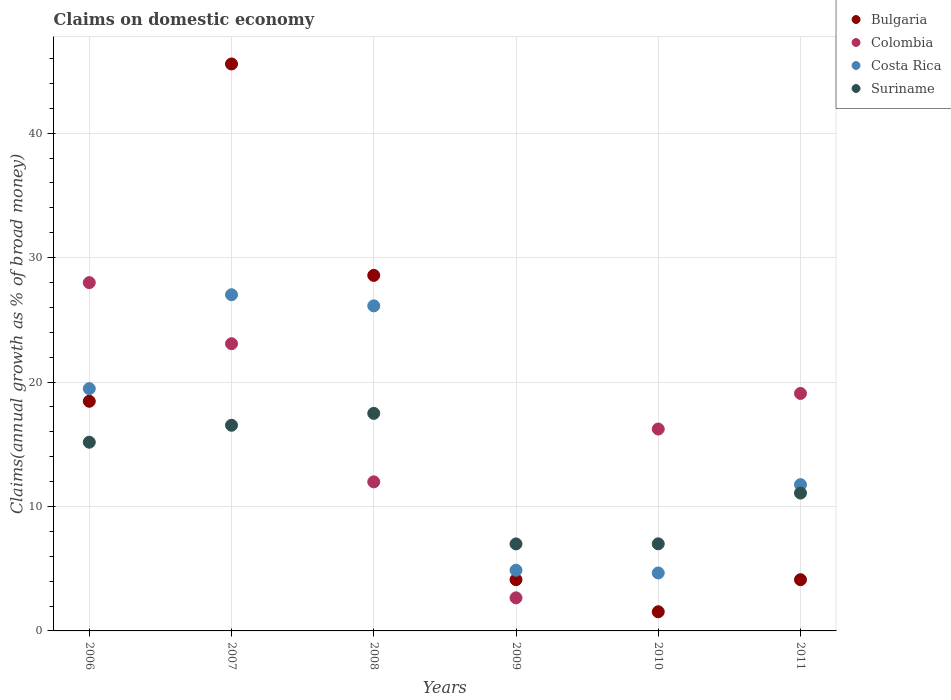How many different coloured dotlines are there?
Your response must be concise. 4. Is the number of dotlines equal to the number of legend labels?
Your response must be concise. Yes. What is the percentage of broad money claimed on domestic economy in Costa Rica in 2007?
Your answer should be very brief. 27.02. Across all years, what is the maximum percentage of broad money claimed on domestic economy in Bulgaria?
Ensure brevity in your answer.  45.56. Across all years, what is the minimum percentage of broad money claimed on domestic economy in Suriname?
Keep it short and to the point. 6.99. In which year was the percentage of broad money claimed on domestic economy in Bulgaria maximum?
Offer a very short reply. 2007. What is the total percentage of broad money claimed on domestic economy in Bulgaria in the graph?
Offer a very short reply. 102.36. What is the difference between the percentage of broad money claimed on domestic economy in Colombia in 2009 and that in 2011?
Your answer should be compact. -16.43. What is the difference between the percentage of broad money claimed on domestic economy in Bulgaria in 2008 and the percentage of broad money claimed on domestic economy in Suriname in 2009?
Make the answer very short. 21.58. What is the average percentage of broad money claimed on domestic economy in Bulgaria per year?
Ensure brevity in your answer.  17.06. In the year 2010, what is the difference between the percentage of broad money claimed on domestic economy in Suriname and percentage of broad money claimed on domestic economy in Costa Rica?
Make the answer very short. 2.34. What is the ratio of the percentage of broad money claimed on domestic economy in Costa Rica in 2006 to that in 2007?
Give a very brief answer. 0.72. Is the percentage of broad money claimed on domestic economy in Costa Rica in 2006 less than that in 2009?
Your response must be concise. No. What is the difference between the highest and the second highest percentage of broad money claimed on domestic economy in Bulgaria?
Keep it short and to the point. 16.99. What is the difference between the highest and the lowest percentage of broad money claimed on domestic economy in Suriname?
Ensure brevity in your answer.  10.49. In how many years, is the percentage of broad money claimed on domestic economy in Costa Rica greater than the average percentage of broad money claimed on domestic economy in Costa Rica taken over all years?
Your answer should be very brief. 3. Is the sum of the percentage of broad money claimed on domestic economy in Suriname in 2006 and 2007 greater than the maximum percentage of broad money claimed on domestic economy in Colombia across all years?
Your answer should be compact. Yes. Is the percentage of broad money claimed on domestic economy in Suriname strictly greater than the percentage of broad money claimed on domestic economy in Costa Rica over the years?
Make the answer very short. No. Is the percentage of broad money claimed on domestic economy in Colombia strictly less than the percentage of broad money claimed on domestic economy in Costa Rica over the years?
Give a very brief answer. No. How many dotlines are there?
Make the answer very short. 4. How many years are there in the graph?
Keep it short and to the point. 6. What is the difference between two consecutive major ticks on the Y-axis?
Your response must be concise. 10. Does the graph contain any zero values?
Your answer should be very brief. No. Does the graph contain grids?
Ensure brevity in your answer.  Yes. How many legend labels are there?
Provide a succinct answer. 4. What is the title of the graph?
Offer a terse response. Claims on domestic economy. Does "Canada" appear as one of the legend labels in the graph?
Your answer should be very brief. No. What is the label or title of the X-axis?
Make the answer very short. Years. What is the label or title of the Y-axis?
Offer a terse response. Claims(annual growth as % of broad money). What is the Claims(annual growth as % of broad money) in Bulgaria in 2006?
Your answer should be compact. 18.45. What is the Claims(annual growth as % of broad money) in Colombia in 2006?
Your response must be concise. 27.99. What is the Claims(annual growth as % of broad money) in Costa Rica in 2006?
Ensure brevity in your answer.  19.47. What is the Claims(annual growth as % of broad money) in Suriname in 2006?
Provide a succinct answer. 15.16. What is the Claims(annual growth as % of broad money) of Bulgaria in 2007?
Your answer should be very brief. 45.56. What is the Claims(annual growth as % of broad money) in Colombia in 2007?
Offer a very short reply. 23.08. What is the Claims(annual growth as % of broad money) of Costa Rica in 2007?
Your response must be concise. 27.02. What is the Claims(annual growth as % of broad money) in Suriname in 2007?
Your answer should be very brief. 16.53. What is the Claims(annual growth as % of broad money) of Bulgaria in 2008?
Provide a short and direct response. 28.57. What is the Claims(annual growth as % of broad money) of Colombia in 2008?
Offer a very short reply. 11.98. What is the Claims(annual growth as % of broad money) in Costa Rica in 2008?
Ensure brevity in your answer.  26.12. What is the Claims(annual growth as % of broad money) in Suriname in 2008?
Provide a short and direct response. 17.48. What is the Claims(annual growth as % of broad money) in Bulgaria in 2009?
Provide a succinct answer. 4.12. What is the Claims(annual growth as % of broad money) of Colombia in 2009?
Your answer should be compact. 2.66. What is the Claims(annual growth as % of broad money) of Costa Rica in 2009?
Ensure brevity in your answer.  4.88. What is the Claims(annual growth as % of broad money) of Suriname in 2009?
Provide a short and direct response. 6.99. What is the Claims(annual growth as % of broad money) in Bulgaria in 2010?
Offer a terse response. 1.54. What is the Claims(annual growth as % of broad money) in Colombia in 2010?
Keep it short and to the point. 16.22. What is the Claims(annual growth as % of broad money) of Costa Rica in 2010?
Make the answer very short. 4.66. What is the Claims(annual growth as % of broad money) in Suriname in 2010?
Keep it short and to the point. 7. What is the Claims(annual growth as % of broad money) in Bulgaria in 2011?
Offer a terse response. 4.12. What is the Claims(annual growth as % of broad money) in Colombia in 2011?
Keep it short and to the point. 19.08. What is the Claims(annual growth as % of broad money) of Costa Rica in 2011?
Your response must be concise. 11.75. What is the Claims(annual growth as % of broad money) of Suriname in 2011?
Make the answer very short. 11.08. Across all years, what is the maximum Claims(annual growth as % of broad money) in Bulgaria?
Provide a succinct answer. 45.56. Across all years, what is the maximum Claims(annual growth as % of broad money) in Colombia?
Your response must be concise. 27.99. Across all years, what is the maximum Claims(annual growth as % of broad money) in Costa Rica?
Offer a very short reply. 27.02. Across all years, what is the maximum Claims(annual growth as % of broad money) of Suriname?
Your answer should be compact. 17.48. Across all years, what is the minimum Claims(annual growth as % of broad money) in Bulgaria?
Give a very brief answer. 1.54. Across all years, what is the minimum Claims(annual growth as % of broad money) in Colombia?
Offer a very short reply. 2.66. Across all years, what is the minimum Claims(annual growth as % of broad money) in Costa Rica?
Give a very brief answer. 4.66. Across all years, what is the minimum Claims(annual growth as % of broad money) of Suriname?
Keep it short and to the point. 6.99. What is the total Claims(annual growth as % of broad money) of Bulgaria in the graph?
Your answer should be compact. 102.36. What is the total Claims(annual growth as % of broad money) in Colombia in the graph?
Keep it short and to the point. 101.01. What is the total Claims(annual growth as % of broad money) of Costa Rica in the graph?
Give a very brief answer. 93.89. What is the total Claims(annual growth as % of broad money) in Suriname in the graph?
Make the answer very short. 74.24. What is the difference between the Claims(annual growth as % of broad money) of Bulgaria in 2006 and that in 2007?
Provide a succinct answer. -27.11. What is the difference between the Claims(annual growth as % of broad money) of Colombia in 2006 and that in 2007?
Make the answer very short. 4.91. What is the difference between the Claims(annual growth as % of broad money) in Costa Rica in 2006 and that in 2007?
Provide a short and direct response. -7.55. What is the difference between the Claims(annual growth as % of broad money) in Suriname in 2006 and that in 2007?
Your answer should be very brief. -1.36. What is the difference between the Claims(annual growth as % of broad money) of Bulgaria in 2006 and that in 2008?
Ensure brevity in your answer.  -10.12. What is the difference between the Claims(annual growth as % of broad money) of Colombia in 2006 and that in 2008?
Ensure brevity in your answer.  16.01. What is the difference between the Claims(annual growth as % of broad money) in Costa Rica in 2006 and that in 2008?
Provide a short and direct response. -6.65. What is the difference between the Claims(annual growth as % of broad money) of Suriname in 2006 and that in 2008?
Keep it short and to the point. -2.32. What is the difference between the Claims(annual growth as % of broad money) of Bulgaria in 2006 and that in 2009?
Offer a terse response. 14.33. What is the difference between the Claims(annual growth as % of broad money) of Colombia in 2006 and that in 2009?
Provide a short and direct response. 25.33. What is the difference between the Claims(annual growth as % of broad money) in Costa Rica in 2006 and that in 2009?
Ensure brevity in your answer.  14.59. What is the difference between the Claims(annual growth as % of broad money) of Suriname in 2006 and that in 2009?
Keep it short and to the point. 8.17. What is the difference between the Claims(annual growth as % of broad money) of Bulgaria in 2006 and that in 2010?
Offer a very short reply. 16.91. What is the difference between the Claims(annual growth as % of broad money) in Colombia in 2006 and that in 2010?
Provide a short and direct response. 11.76. What is the difference between the Claims(annual growth as % of broad money) of Costa Rica in 2006 and that in 2010?
Your answer should be compact. 14.81. What is the difference between the Claims(annual growth as % of broad money) in Suriname in 2006 and that in 2010?
Your answer should be compact. 8.17. What is the difference between the Claims(annual growth as % of broad money) in Bulgaria in 2006 and that in 2011?
Keep it short and to the point. 14.34. What is the difference between the Claims(annual growth as % of broad money) in Colombia in 2006 and that in 2011?
Provide a succinct answer. 8.9. What is the difference between the Claims(annual growth as % of broad money) of Costa Rica in 2006 and that in 2011?
Provide a short and direct response. 7.72. What is the difference between the Claims(annual growth as % of broad money) in Suriname in 2006 and that in 2011?
Your answer should be very brief. 4.09. What is the difference between the Claims(annual growth as % of broad money) in Bulgaria in 2007 and that in 2008?
Give a very brief answer. 16.99. What is the difference between the Claims(annual growth as % of broad money) in Colombia in 2007 and that in 2008?
Provide a succinct answer. 11.1. What is the difference between the Claims(annual growth as % of broad money) of Costa Rica in 2007 and that in 2008?
Give a very brief answer. 0.89. What is the difference between the Claims(annual growth as % of broad money) of Suriname in 2007 and that in 2008?
Provide a succinct answer. -0.96. What is the difference between the Claims(annual growth as % of broad money) of Bulgaria in 2007 and that in 2009?
Offer a terse response. 41.44. What is the difference between the Claims(annual growth as % of broad money) in Colombia in 2007 and that in 2009?
Your answer should be very brief. 20.42. What is the difference between the Claims(annual growth as % of broad money) in Costa Rica in 2007 and that in 2009?
Give a very brief answer. 22.14. What is the difference between the Claims(annual growth as % of broad money) of Suriname in 2007 and that in 2009?
Your answer should be compact. 9.53. What is the difference between the Claims(annual growth as % of broad money) in Bulgaria in 2007 and that in 2010?
Offer a terse response. 44.02. What is the difference between the Claims(annual growth as % of broad money) of Colombia in 2007 and that in 2010?
Give a very brief answer. 6.86. What is the difference between the Claims(annual growth as % of broad money) in Costa Rica in 2007 and that in 2010?
Your answer should be compact. 22.36. What is the difference between the Claims(annual growth as % of broad money) in Suriname in 2007 and that in 2010?
Offer a very short reply. 9.53. What is the difference between the Claims(annual growth as % of broad money) of Bulgaria in 2007 and that in 2011?
Provide a succinct answer. 41.44. What is the difference between the Claims(annual growth as % of broad money) in Colombia in 2007 and that in 2011?
Ensure brevity in your answer.  4. What is the difference between the Claims(annual growth as % of broad money) of Costa Rica in 2007 and that in 2011?
Make the answer very short. 15.26. What is the difference between the Claims(annual growth as % of broad money) of Suriname in 2007 and that in 2011?
Your answer should be very brief. 5.45. What is the difference between the Claims(annual growth as % of broad money) of Bulgaria in 2008 and that in 2009?
Give a very brief answer. 24.45. What is the difference between the Claims(annual growth as % of broad money) of Colombia in 2008 and that in 2009?
Your answer should be compact. 9.32. What is the difference between the Claims(annual growth as % of broad money) in Costa Rica in 2008 and that in 2009?
Offer a terse response. 21.25. What is the difference between the Claims(annual growth as % of broad money) of Suriname in 2008 and that in 2009?
Provide a short and direct response. 10.49. What is the difference between the Claims(annual growth as % of broad money) of Bulgaria in 2008 and that in 2010?
Offer a very short reply. 27.03. What is the difference between the Claims(annual growth as % of broad money) in Colombia in 2008 and that in 2010?
Offer a terse response. -4.25. What is the difference between the Claims(annual growth as % of broad money) in Costa Rica in 2008 and that in 2010?
Your answer should be very brief. 21.46. What is the difference between the Claims(annual growth as % of broad money) in Suriname in 2008 and that in 2010?
Offer a very short reply. 10.48. What is the difference between the Claims(annual growth as % of broad money) in Bulgaria in 2008 and that in 2011?
Offer a very short reply. 24.45. What is the difference between the Claims(annual growth as % of broad money) in Colombia in 2008 and that in 2011?
Offer a terse response. -7.11. What is the difference between the Claims(annual growth as % of broad money) in Costa Rica in 2008 and that in 2011?
Your answer should be compact. 14.37. What is the difference between the Claims(annual growth as % of broad money) of Suriname in 2008 and that in 2011?
Ensure brevity in your answer.  6.4. What is the difference between the Claims(annual growth as % of broad money) of Bulgaria in 2009 and that in 2010?
Ensure brevity in your answer.  2.58. What is the difference between the Claims(annual growth as % of broad money) in Colombia in 2009 and that in 2010?
Offer a terse response. -13.57. What is the difference between the Claims(annual growth as % of broad money) of Costa Rica in 2009 and that in 2010?
Provide a short and direct response. 0.22. What is the difference between the Claims(annual growth as % of broad money) of Suriname in 2009 and that in 2010?
Ensure brevity in your answer.  -0.01. What is the difference between the Claims(annual growth as % of broad money) of Bulgaria in 2009 and that in 2011?
Your answer should be very brief. 0. What is the difference between the Claims(annual growth as % of broad money) of Colombia in 2009 and that in 2011?
Keep it short and to the point. -16.43. What is the difference between the Claims(annual growth as % of broad money) in Costa Rica in 2009 and that in 2011?
Your answer should be very brief. -6.88. What is the difference between the Claims(annual growth as % of broad money) of Suriname in 2009 and that in 2011?
Your answer should be very brief. -4.09. What is the difference between the Claims(annual growth as % of broad money) of Bulgaria in 2010 and that in 2011?
Your answer should be compact. -2.58. What is the difference between the Claims(annual growth as % of broad money) of Colombia in 2010 and that in 2011?
Offer a terse response. -2.86. What is the difference between the Claims(annual growth as % of broad money) of Costa Rica in 2010 and that in 2011?
Make the answer very short. -7.1. What is the difference between the Claims(annual growth as % of broad money) in Suriname in 2010 and that in 2011?
Provide a succinct answer. -4.08. What is the difference between the Claims(annual growth as % of broad money) of Bulgaria in 2006 and the Claims(annual growth as % of broad money) of Colombia in 2007?
Your answer should be compact. -4.63. What is the difference between the Claims(annual growth as % of broad money) of Bulgaria in 2006 and the Claims(annual growth as % of broad money) of Costa Rica in 2007?
Provide a short and direct response. -8.56. What is the difference between the Claims(annual growth as % of broad money) of Bulgaria in 2006 and the Claims(annual growth as % of broad money) of Suriname in 2007?
Your response must be concise. 1.93. What is the difference between the Claims(annual growth as % of broad money) of Colombia in 2006 and the Claims(annual growth as % of broad money) of Costa Rica in 2007?
Provide a short and direct response. 0.97. What is the difference between the Claims(annual growth as % of broad money) in Colombia in 2006 and the Claims(annual growth as % of broad money) in Suriname in 2007?
Give a very brief answer. 11.46. What is the difference between the Claims(annual growth as % of broad money) of Costa Rica in 2006 and the Claims(annual growth as % of broad money) of Suriname in 2007?
Your answer should be compact. 2.94. What is the difference between the Claims(annual growth as % of broad money) in Bulgaria in 2006 and the Claims(annual growth as % of broad money) in Colombia in 2008?
Give a very brief answer. 6.48. What is the difference between the Claims(annual growth as % of broad money) in Bulgaria in 2006 and the Claims(annual growth as % of broad money) in Costa Rica in 2008?
Keep it short and to the point. -7.67. What is the difference between the Claims(annual growth as % of broad money) of Colombia in 2006 and the Claims(annual growth as % of broad money) of Costa Rica in 2008?
Offer a very short reply. 1.87. What is the difference between the Claims(annual growth as % of broad money) of Colombia in 2006 and the Claims(annual growth as % of broad money) of Suriname in 2008?
Provide a succinct answer. 10.51. What is the difference between the Claims(annual growth as % of broad money) of Costa Rica in 2006 and the Claims(annual growth as % of broad money) of Suriname in 2008?
Your answer should be very brief. 1.99. What is the difference between the Claims(annual growth as % of broad money) of Bulgaria in 2006 and the Claims(annual growth as % of broad money) of Colombia in 2009?
Provide a short and direct response. 15.8. What is the difference between the Claims(annual growth as % of broad money) of Bulgaria in 2006 and the Claims(annual growth as % of broad money) of Costa Rica in 2009?
Offer a very short reply. 13.58. What is the difference between the Claims(annual growth as % of broad money) in Bulgaria in 2006 and the Claims(annual growth as % of broad money) in Suriname in 2009?
Offer a terse response. 11.46. What is the difference between the Claims(annual growth as % of broad money) in Colombia in 2006 and the Claims(annual growth as % of broad money) in Costa Rica in 2009?
Keep it short and to the point. 23.11. What is the difference between the Claims(annual growth as % of broad money) in Colombia in 2006 and the Claims(annual growth as % of broad money) in Suriname in 2009?
Offer a terse response. 21. What is the difference between the Claims(annual growth as % of broad money) of Costa Rica in 2006 and the Claims(annual growth as % of broad money) of Suriname in 2009?
Ensure brevity in your answer.  12.48. What is the difference between the Claims(annual growth as % of broad money) in Bulgaria in 2006 and the Claims(annual growth as % of broad money) in Colombia in 2010?
Make the answer very short. 2.23. What is the difference between the Claims(annual growth as % of broad money) in Bulgaria in 2006 and the Claims(annual growth as % of broad money) in Costa Rica in 2010?
Your answer should be compact. 13.8. What is the difference between the Claims(annual growth as % of broad money) in Bulgaria in 2006 and the Claims(annual growth as % of broad money) in Suriname in 2010?
Your answer should be very brief. 11.46. What is the difference between the Claims(annual growth as % of broad money) in Colombia in 2006 and the Claims(annual growth as % of broad money) in Costa Rica in 2010?
Your answer should be compact. 23.33. What is the difference between the Claims(annual growth as % of broad money) of Colombia in 2006 and the Claims(annual growth as % of broad money) of Suriname in 2010?
Offer a terse response. 20.99. What is the difference between the Claims(annual growth as % of broad money) of Costa Rica in 2006 and the Claims(annual growth as % of broad money) of Suriname in 2010?
Give a very brief answer. 12.47. What is the difference between the Claims(annual growth as % of broad money) in Bulgaria in 2006 and the Claims(annual growth as % of broad money) in Colombia in 2011?
Your answer should be very brief. -0.63. What is the difference between the Claims(annual growth as % of broad money) of Bulgaria in 2006 and the Claims(annual growth as % of broad money) of Costa Rica in 2011?
Ensure brevity in your answer.  6.7. What is the difference between the Claims(annual growth as % of broad money) of Bulgaria in 2006 and the Claims(annual growth as % of broad money) of Suriname in 2011?
Your answer should be very brief. 7.38. What is the difference between the Claims(annual growth as % of broad money) of Colombia in 2006 and the Claims(annual growth as % of broad money) of Costa Rica in 2011?
Keep it short and to the point. 16.23. What is the difference between the Claims(annual growth as % of broad money) in Colombia in 2006 and the Claims(annual growth as % of broad money) in Suriname in 2011?
Keep it short and to the point. 16.91. What is the difference between the Claims(annual growth as % of broad money) of Costa Rica in 2006 and the Claims(annual growth as % of broad money) of Suriname in 2011?
Provide a short and direct response. 8.39. What is the difference between the Claims(annual growth as % of broad money) in Bulgaria in 2007 and the Claims(annual growth as % of broad money) in Colombia in 2008?
Your response must be concise. 33.58. What is the difference between the Claims(annual growth as % of broad money) of Bulgaria in 2007 and the Claims(annual growth as % of broad money) of Costa Rica in 2008?
Provide a succinct answer. 19.44. What is the difference between the Claims(annual growth as % of broad money) of Bulgaria in 2007 and the Claims(annual growth as % of broad money) of Suriname in 2008?
Offer a terse response. 28.08. What is the difference between the Claims(annual growth as % of broad money) in Colombia in 2007 and the Claims(annual growth as % of broad money) in Costa Rica in 2008?
Offer a terse response. -3.04. What is the difference between the Claims(annual growth as % of broad money) of Colombia in 2007 and the Claims(annual growth as % of broad money) of Suriname in 2008?
Your response must be concise. 5.6. What is the difference between the Claims(annual growth as % of broad money) in Costa Rica in 2007 and the Claims(annual growth as % of broad money) in Suriname in 2008?
Ensure brevity in your answer.  9.53. What is the difference between the Claims(annual growth as % of broad money) of Bulgaria in 2007 and the Claims(annual growth as % of broad money) of Colombia in 2009?
Your answer should be compact. 42.9. What is the difference between the Claims(annual growth as % of broad money) of Bulgaria in 2007 and the Claims(annual growth as % of broad money) of Costa Rica in 2009?
Your response must be concise. 40.68. What is the difference between the Claims(annual growth as % of broad money) in Bulgaria in 2007 and the Claims(annual growth as % of broad money) in Suriname in 2009?
Give a very brief answer. 38.57. What is the difference between the Claims(annual growth as % of broad money) in Colombia in 2007 and the Claims(annual growth as % of broad money) in Costa Rica in 2009?
Your response must be concise. 18.2. What is the difference between the Claims(annual growth as % of broad money) of Colombia in 2007 and the Claims(annual growth as % of broad money) of Suriname in 2009?
Provide a short and direct response. 16.09. What is the difference between the Claims(annual growth as % of broad money) of Costa Rica in 2007 and the Claims(annual growth as % of broad money) of Suriname in 2009?
Offer a terse response. 20.02. What is the difference between the Claims(annual growth as % of broad money) of Bulgaria in 2007 and the Claims(annual growth as % of broad money) of Colombia in 2010?
Provide a short and direct response. 29.34. What is the difference between the Claims(annual growth as % of broad money) in Bulgaria in 2007 and the Claims(annual growth as % of broad money) in Costa Rica in 2010?
Your answer should be very brief. 40.9. What is the difference between the Claims(annual growth as % of broad money) of Bulgaria in 2007 and the Claims(annual growth as % of broad money) of Suriname in 2010?
Your answer should be very brief. 38.56. What is the difference between the Claims(annual growth as % of broad money) in Colombia in 2007 and the Claims(annual growth as % of broad money) in Costa Rica in 2010?
Provide a succinct answer. 18.42. What is the difference between the Claims(annual growth as % of broad money) of Colombia in 2007 and the Claims(annual growth as % of broad money) of Suriname in 2010?
Offer a terse response. 16.08. What is the difference between the Claims(annual growth as % of broad money) of Costa Rica in 2007 and the Claims(annual growth as % of broad money) of Suriname in 2010?
Make the answer very short. 20.02. What is the difference between the Claims(annual growth as % of broad money) of Bulgaria in 2007 and the Claims(annual growth as % of broad money) of Colombia in 2011?
Your answer should be compact. 26.48. What is the difference between the Claims(annual growth as % of broad money) in Bulgaria in 2007 and the Claims(annual growth as % of broad money) in Costa Rica in 2011?
Your response must be concise. 33.81. What is the difference between the Claims(annual growth as % of broad money) in Bulgaria in 2007 and the Claims(annual growth as % of broad money) in Suriname in 2011?
Your response must be concise. 34.48. What is the difference between the Claims(annual growth as % of broad money) in Colombia in 2007 and the Claims(annual growth as % of broad money) in Costa Rica in 2011?
Ensure brevity in your answer.  11.33. What is the difference between the Claims(annual growth as % of broad money) of Colombia in 2007 and the Claims(annual growth as % of broad money) of Suriname in 2011?
Your response must be concise. 12. What is the difference between the Claims(annual growth as % of broad money) of Costa Rica in 2007 and the Claims(annual growth as % of broad money) of Suriname in 2011?
Offer a terse response. 15.94. What is the difference between the Claims(annual growth as % of broad money) in Bulgaria in 2008 and the Claims(annual growth as % of broad money) in Colombia in 2009?
Offer a very short reply. 25.91. What is the difference between the Claims(annual growth as % of broad money) in Bulgaria in 2008 and the Claims(annual growth as % of broad money) in Costa Rica in 2009?
Ensure brevity in your answer.  23.69. What is the difference between the Claims(annual growth as % of broad money) of Bulgaria in 2008 and the Claims(annual growth as % of broad money) of Suriname in 2009?
Provide a short and direct response. 21.58. What is the difference between the Claims(annual growth as % of broad money) in Colombia in 2008 and the Claims(annual growth as % of broad money) in Costa Rica in 2009?
Ensure brevity in your answer.  7.1. What is the difference between the Claims(annual growth as % of broad money) of Colombia in 2008 and the Claims(annual growth as % of broad money) of Suriname in 2009?
Offer a very short reply. 4.99. What is the difference between the Claims(annual growth as % of broad money) in Costa Rica in 2008 and the Claims(annual growth as % of broad money) in Suriname in 2009?
Your answer should be compact. 19.13. What is the difference between the Claims(annual growth as % of broad money) of Bulgaria in 2008 and the Claims(annual growth as % of broad money) of Colombia in 2010?
Provide a short and direct response. 12.35. What is the difference between the Claims(annual growth as % of broad money) in Bulgaria in 2008 and the Claims(annual growth as % of broad money) in Costa Rica in 2010?
Ensure brevity in your answer.  23.91. What is the difference between the Claims(annual growth as % of broad money) in Bulgaria in 2008 and the Claims(annual growth as % of broad money) in Suriname in 2010?
Your answer should be very brief. 21.57. What is the difference between the Claims(annual growth as % of broad money) of Colombia in 2008 and the Claims(annual growth as % of broad money) of Costa Rica in 2010?
Your answer should be compact. 7.32. What is the difference between the Claims(annual growth as % of broad money) of Colombia in 2008 and the Claims(annual growth as % of broad money) of Suriname in 2010?
Provide a short and direct response. 4.98. What is the difference between the Claims(annual growth as % of broad money) in Costa Rica in 2008 and the Claims(annual growth as % of broad money) in Suriname in 2010?
Your answer should be compact. 19.12. What is the difference between the Claims(annual growth as % of broad money) in Bulgaria in 2008 and the Claims(annual growth as % of broad money) in Colombia in 2011?
Offer a very short reply. 9.49. What is the difference between the Claims(annual growth as % of broad money) in Bulgaria in 2008 and the Claims(annual growth as % of broad money) in Costa Rica in 2011?
Ensure brevity in your answer.  16.82. What is the difference between the Claims(annual growth as % of broad money) of Bulgaria in 2008 and the Claims(annual growth as % of broad money) of Suriname in 2011?
Ensure brevity in your answer.  17.49. What is the difference between the Claims(annual growth as % of broad money) in Colombia in 2008 and the Claims(annual growth as % of broad money) in Costa Rica in 2011?
Provide a short and direct response. 0.22. What is the difference between the Claims(annual growth as % of broad money) of Colombia in 2008 and the Claims(annual growth as % of broad money) of Suriname in 2011?
Your answer should be compact. 0.9. What is the difference between the Claims(annual growth as % of broad money) of Costa Rica in 2008 and the Claims(annual growth as % of broad money) of Suriname in 2011?
Offer a very short reply. 15.04. What is the difference between the Claims(annual growth as % of broad money) in Bulgaria in 2009 and the Claims(annual growth as % of broad money) in Colombia in 2010?
Offer a very short reply. -12.1. What is the difference between the Claims(annual growth as % of broad money) of Bulgaria in 2009 and the Claims(annual growth as % of broad money) of Costa Rica in 2010?
Make the answer very short. -0.54. What is the difference between the Claims(annual growth as % of broad money) in Bulgaria in 2009 and the Claims(annual growth as % of broad money) in Suriname in 2010?
Your answer should be compact. -2.88. What is the difference between the Claims(annual growth as % of broad money) in Colombia in 2009 and the Claims(annual growth as % of broad money) in Costa Rica in 2010?
Your response must be concise. -2. What is the difference between the Claims(annual growth as % of broad money) of Colombia in 2009 and the Claims(annual growth as % of broad money) of Suriname in 2010?
Offer a very short reply. -4.34. What is the difference between the Claims(annual growth as % of broad money) of Costa Rica in 2009 and the Claims(annual growth as % of broad money) of Suriname in 2010?
Your response must be concise. -2.12. What is the difference between the Claims(annual growth as % of broad money) of Bulgaria in 2009 and the Claims(annual growth as % of broad money) of Colombia in 2011?
Give a very brief answer. -14.96. What is the difference between the Claims(annual growth as % of broad money) in Bulgaria in 2009 and the Claims(annual growth as % of broad money) in Costa Rica in 2011?
Provide a short and direct response. -7.63. What is the difference between the Claims(annual growth as % of broad money) in Bulgaria in 2009 and the Claims(annual growth as % of broad money) in Suriname in 2011?
Offer a very short reply. -6.96. What is the difference between the Claims(annual growth as % of broad money) of Colombia in 2009 and the Claims(annual growth as % of broad money) of Costa Rica in 2011?
Your answer should be compact. -9.1. What is the difference between the Claims(annual growth as % of broad money) of Colombia in 2009 and the Claims(annual growth as % of broad money) of Suriname in 2011?
Your response must be concise. -8.42. What is the difference between the Claims(annual growth as % of broad money) of Costa Rica in 2009 and the Claims(annual growth as % of broad money) of Suriname in 2011?
Offer a terse response. -6.2. What is the difference between the Claims(annual growth as % of broad money) of Bulgaria in 2010 and the Claims(annual growth as % of broad money) of Colombia in 2011?
Give a very brief answer. -17.54. What is the difference between the Claims(annual growth as % of broad money) of Bulgaria in 2010 and the Claims(annual growth as % of broad money) of Costa Rica in 2011?
Your answer should be compact. -10.21. What is the difference between the Claims(annual growth as % of broad money) of Bulgaria in 2010 and the Claims(annual growth as % of broad money) of Suriname in 2011?
Give a very brief answer. -9.54. What is the difference between the Claims(annual growth as % of broad money) in Colombia in 2010 and the Claims(annual growth as % of broad money) in Costa Rica in 2011?
Provide a succinct answer. 4.47. What is the difference between the Claims(annual growth as % of broad money) in Colombia in 2010 and the Claims(annual growth as % of broad money) in Suriname in 2011?
Your answer should be compact. 5.15. What is the difference between the Claims(annual growth as % of broad money) in Costa Rica in 2010 and the Claims(annual growth as % of broad money) in Suriname in 2011?
Your response must be concise. -6.42. What is the average Claims(annual growth as % of broad money) in Bulgaria per year?
Make the answer very short. 17.06. What is the average Claims(annual growth as % of broad money) of Colombia per year?
Your answer should be compact. 16.84. What is the average Claims(annual growth as % of broad money) of Costa Rica per year?
Ensure brevity in your answer.  15.65. What is the average Claims(annual growth as % of broad money) in Suriname per year?
Keep it short and to the point. 12.37. In the year 2006, what is the difference between the Claims(annual growth as % of broad money) of Bulgaria and Claims(annual growth as % of broad money) of Colombia?
Offer a terse response. -9.53. In the year 2006, what is the difference between the Claims(annual growth as % of broad money) of Bulgaria and Claims(annual growth as % of broad money) of Costa Rica?
Keep it short and to the point. -1.02. In the year 2006, what is the difference between the Claims(annual growth as % of broad money) of Bulgaria and Claims(annual growth as % of broad money) of Suriname?
Make the answer very short. 3.29. In the year 2006, what is the difference between the Claims(annual growth as % of broad money) in Colombia and Claims(annual growth as % of broad money) in Costa Rica?
Make the answer very short. 8.52. In the year 2006, what is the difference between the Claims(annual growth as % of broad money) in Colombia and Claims(annual growth as % of broad money) in Suriname?
Offer a very short reply. 12.82. In the year 2006, what is the difference between the Claims(annual growth as % of broad money) in Costa Rica and Claims(annual growth as % of broad money) in Suriname?
Provide a short and direct response. 4.31. In the year 2007, what is the difference between the Claims(annual growth as % of broad money) of Bulgaria and Claims(annual growth as % of broad money) of Colombia?
Provide a short and direct response. 22.48. In the year 2007, what is the difference between the Claims(annual growth as % of broad money) of Bulgaria and Claims(annual growth as % of broad money) of Costa Rica?
Provide a succinct answer. 18.54. In the year 2007, what is the difference between the Claims(annual growth as % of broad money) of Bulgaria and Claims(annual growth as % of broad money) of Suriname?
Keep it short and to the point. 29.03. In the year 2007, what is the difference between the Claims(annual growth as % of broad money) in Colombia and Claims(annual growth as % of broad money) in Costa Rica?
Provide a short and direct response. -3.94. In the year 2007, what is the difference between the Claims(annual growth as % of broad money) in Colombia and Claims(annual growth as % of broad money) in Suriname?
Provide a succinct answer. 6.55. In the year 2007, what is the difference between the Claims(annual growth as % of broad money) of Costa Rica and Claims(annual growth as % of broad money) of Suriname?
Keep it short and to the point. 10.49. In the year 2008, what is the difference between the Claims(annual growth as % of broad money) in Bulgaria and Claims(annual growth as % of broad money) in Colombia?
Give a very brief answer. 16.59. In the year 2008, what is the difference between the Claims(annual growth as % of broad money) in Bulgaria and Claims(annual growth as % of broad money) in Costa Rica?
Make the answer very short. 2.45. In the year 2008, what is the difference between the Claims(annual growth as % of broad money) of Bulgaria and Claims(annual growth as % of broad money) of Suriname?
Offer a terse response. 11.09. In the year 2008, what is the difference between the Claims(annual growth as % of broad money) of Colombia and Claims(annual growth as % of broad money) of Costa Rica?
Keep it short and to the point. -14.14. In the year 2008, what is the difference between the Claims(annual growth as % of broad money) in Colombia and Claims(annual growth as % of broad money) in Suriname?
Offer a terse response. -5.5. In the year 2008, what is the difference between the Claims(annual growth as % of broad money) in Costa Rica and Claims(annual growth as % of broad money) in Suriname?
Your response must be concise. 8.64. In the year 2009, what is the difference between the Claims(annual growth as % of broad money) in Bulgaria and Claims(annual growth as % of broad money) in Colombia?
Make the answer very short. 1.46. In the year 2009, what is the difference between the Claims(annual growth as % of broad money) in Bulgaria and Claims(annual growth as % of broad money) in Costa Rica?
Offer a terse response. -0.76. In the year 2009, what is the difference between the Claims(annual growth as % of broad money) in Bulgaria and Claims(annual growth as % of broad money) in Suriname?
Provide a short and direct response. -2.87. In the year 2009, what is the difference between the Claims(annual growth as % of broad money) in Colombia and Claims(annual growth as % of broad money) in Costa Rica?
Give a very brief answer. -2.22. In the year 2009, what is the difference between the Claims(annual growth as % of broad money) in Colombia and Claims(annual growth as % of broad money) in Suriname?
Your response must be concise. -4.34. In the year 2009, what is the difference between the Claims(annual growth as % of broad money) of Costa Rica and Claims(annual growth as % of broad money) of Suriname?
Give a very brief answer. -2.12. In the year 2010, what is the difference between the Claims(annual growth as % of broad money) of Bulgaria and Claims(annual growth as % of broad money) of Colombia?
Ensure brevity in your answer.  -14.68. In the year 2010, what is the difference between the Claims(annual growth as % of broad money) of Bulgaria and Claims(annual growth as % of broad money) of Costa Rica?
Keep it short and to the point. -3.12. In the year 2010, what is the difference between the Claims(annual growth as % of broad money) of Bulgaria and Claims(annual growth as % of broad money) of Suriname?
Offer a very short reply. -5.46. In the year 2010, what is the difference between the Claims(annual growth as % of broad money) in Colombia and Claims(annual growth as % of broad money) in Costa Rica?
Your response must be concise. 11.57. In the year 2010, what is the difference between the Claims(annual growth as % of broad money) of Colombia and Claims(annual growth as % of broad money) of Suriname?
Provide a short and direct response. 9.23. In the year 2010, what is the difference between the Claims(annual growth as % of broad money) in Costa Rica and Claims(annual growth as % of broad money) in Suriname?
Offer a terse response. -2.34. In the year 2011, what is the difference between the Claims(annual growth as % of broad money) in Bulgaria and Claims(annual growth as % of broad money) in Colombia?
Offer a very short reply. -14.97. In the year 2011, what is the difference between the Claims(annual growth as % of broad money) of Bulgaria and Claims(annual growth as % of broad money) of Costa Rica?
Ensure brevity in your answer.  -7.64. In the year 2011, what is the difference between the Claims(annual growth as % of broad money) of Bulgaria and Claims(annual growth as % of broad money) of Suriname?
Ensure brevity in your answer.  -6.96. In the year 2011, what is the difference between the Claims(annual growth as % of broad money) of Colombia and Claims(annual growth as % of broad money) of Costa Rica?
Give a very brief answer. 7.33. In the year 2011, what is the difference between the Claims(annual growth as % of broad money) in Colombia and Claims(annual growth as % of broad money) in Suriname?
Offer a terse response. 8. In the year 2011, what is the difference between the Claims(annual growth as % of broad money) in Costa Rica and Claims(annual growth as % of broad money) in Suriname?
Keep it short and to the point. 0.68. What is the ratio of the Claims(annual growth as % of broad money) in Bulgaria in 2006 to that in 2007?
Provide a succinct answer. 0.41. What is the ratio of the Claims(annual growth as % of broad money) of Colombia in 2006 to that in 2007?
Ensure brevity in your answer.  1.21. What is the ratio of the Claims(annual growth as % of broad money) of Costa Rica in 2006 to that in 2007?
Your answer should be very brief. 0.72. What is the ratio of the Claims(annual growth as % of broad money) in Suriname in 2006 to that in 2007?
Your response must be concise. 0.92. What is the ratio of the Claims(annual growth as % of broad money) of Bulgaria in 2006 to that in 2008?
Provide a succinct answer. 0.65. What is the ratio of the Claims(annual growth as % of broad money) of Colombia in 2006 to that in 2008?
Your answer should be compact. 2.34. What is the ratio of the Claims(annual growth as % of broad money) in Costa Rica in 2006 to that in 2008?
Ensure brevity in your answer.  0.75. What is the ratio of the Claims(annual growth as % of broad money) of Suriname in 2006 to that in 2008?
Your response must be concise. 0.87. What is the ratio of the Claims(annual growth as % of broad money) in Bulgaria in 2006 to that in 2009?
Offer a terse response. 4.48. What is the ratio of the Claims(annual growth as % of broad money) in Colombia in 2006 to that in 2009?
Your answer should be compact. 10.53. What is the ratio of the Claims(annual growth as % of broad money) in Costa Rica in 2006 to that in 2009?
Give a very brief answer. 3.99. What is the ratio of the Claims(annual growth as % of broad money) in Suriname in 2006 to that in 2009?
Make the answer very short. 2.17. What is the ratio of the Claims(annual growth as % of broad money) in Bulgaria in 2006 to that in 2010?
Make the answer very short. 11.98. What is the ratio of the Claims(annual growth as % of broad money) in Colombia in 2006 to that in 2010?
Your response must be concise. 1.73. What is the ratio of the Claims(annual growth as % of broad money) in Costa Rica in 2006 to that in 2010?
Keep it short and to the point. 4.18. What is the ratio of the Claims(annual growth as % of broad money) in Suriname in 2006 to that in 2010?
Your response must be concise. 2.17. What is the ratio of the Claims(annual growth as % of broad money) in Bulgaria in 2006 to that in 2011?
Your answer should be very brief. 4.48. What is the ratio of the Claims(annual growth as % of broad money) of Colombia in 2006 to that in 2011?
Offer a terse response. 1.47. What is the ratio of the Claims(annual growth as % of broad money) in Costa Rica in 2006 to that in 2011?
Ensure brevity in your answer.  1.66. What is the ratio of the Claims(annual growth as % of broad money) in Suriname in 2006 to that in 2011?
Your answer should be very brief. 1.37. What is the ratio of the Claims(annual growth as % of broad money) in Bulgaria in 2007 to that in 2008?
Offer a terse response. 1.59. What is the ratio of the Claims(annual growth as % of broad money) of Colombia in 2007 to that in 2008?
Give a very brief answer. 1.93. What is the ratio of the Claims(annual growth as % of broad money) in Costa Rica in 2007 to that in 2008?
Keep it short and to the point. 1.03. What is the ratio of the Claims(annual growth as % of broad money) of Suriname in 2007 to that in 2008?
Offer a terse response. 0.95. What is the ratio of the Claims(annual growth as % of broad money) in Bulgaria in 2007 to that in 2009?
Provide a succinct answer. 11.06. What is the ratio of the Claims(annual growth as % of broad money) of Colombia in 2007 to that in 2009?
Keep it short and to the point. 8.69. What is the ratio of the Claims(annual growth as % of broad money) of Costa Rica in 2007 to that in 2009?
Provide a short and direct response. 5.54. What is the ratio of the Claims(annual growth as % of broad money) in Suriname in 2007 to that in 2009?
Ensure brevity in your answer.  2.36. What is the ratio of the Claims(annual growth as % of broad money) of Bulgaria in 2007 to that in 2010?
Make the answer very short. 29.57. What is the ratio of the Claims(annual growth as % of broad money) of Colombia in 2007 to that in 2010?
Your answer should be very brief. 1.42. What is the ratio of the Claims(annual growth as % of broad money) in Costa Rica in 2007 to that in 2010?
Give a very brief answer. 5.8. What is the ratio of the Claims(annual growth as % of broad money) of Suriname in 2007 to that in 2010?
Keep it short and to the point. 2.36. What is the ratio of the Claims(annual growth as % of broad money) of Bulgaria in 2007 to that in 2011?
Give a very brief answer. 11.07. What is the ratio of the Claims(annual growth as % of broad money) in Colombia in 2007 to that in 2011?
Offer a terse response. 1.21. What is the ratio of the Claims(annual growth as % of broad money) of Costa Rica in 2007 to that in 2011?
Your response must be concise. 2.3. What is the ratio of the Claims(annual growth as % of broad money) of Suriname in 2007 to that in 2011?
Provide a short and direct response. 1.49. What is the ratio of the Claims(annual growth as % of broad money) in Bulgaria in 2008 to that in 2009?
Offer a terse response. 6.94. What is the ratio of the Claims(annual growth as % of broad money) in Colombia in 2008 to that in 2009?
Your response must be concise. 4.51. What is the ratio of the Claims(annual growth as % of broad money) of Costa Rica in 2008 to that in 2009?
Your answer should be very brief. 5.36. What is the ratio of the Claims(annual growth as % of broad money) in Suriname in 2008 to that in 2009?
Provide a short and direct response. 2.5. What is the ratio of the Claims(annual growth as % of broad money) of Bulgaria in 2008 to that in 2010?
Give a very brief answer. 18.55. What is the ratio of the Claims(annual growth as % of broad money) of Colombia in 2008 to that in 2010?
Ensure brevity in your answer.  0.74. What is the ratio of the Claims(annual growth as % of broad money) of Costa Rica in 2008 to that in 2010?
Your answer should be very brief. 5.61. What is the ratio of the Claims(annual growth as % of broad money) of Suriname in 2008 to that in 2010?
Make the answer very short. 2.5. What is the ratio of the Claims(annual growth as % of broad money) of Bulgaria in 2008 to that in 2011?
Offer a terse response. 6.94. What is the ratio of the Claims(annual growth as % of broad money) in Colombia in 2008 to that in 2011?
Offer a terse response. 0.63. What is the ratio of the Claims(annual growth as % of broad money) in Costa Rica in 2008 to that in 2011?
Offer a terse response. 2.22. What is the ratio of the Claims(annual growth as % of broad money) of Suriname in 2008 to that in 2011?
Ensure brevity in your answer.  1.58. What is the ratio of the Claims(annual growth as % of broad money) of Bulgaria in 2009 to that in 2010?
Keep it short and to the point. 2.67. What is the ratio of the Claims(annual growth as % of broad money) in Colombia in 2009 to that in 2010?
Your answer should be very brief. 0.16. What is the ratio of the Claims(annual growth as % of broad money) of Costa Rica in 2009 to that in 2010?
Your answer should be compact. 1.05. What is the ratio of the Claims(annual growth as % of broad money) of Bulgaria in 2009 to that in 2011?
Provide a short and direct response. 1. What is the ratio of the Claims(annual growth as % of broad money) of Colombia in 2009 to that in 2011?
Make the answer very short. 0.14. What is the ratio of the Claims(annual growth as % of broad money) in Costa Rica in 2009 to that in 2011?
Your response must be concise. 0.41. What is the ratio of the Claims(annual growth as % of broad money) in Suriname in 2009 to that in 2011?
Offer a very short reply. 0.63. What is the ratio of the Claims(annual growth as % of broad money) in Bulgaria in 2010 to that in 2011?
Offer a very short reply. 0.37. What is the ratio of the Claims(annual growth as % of broad money) in Colombia in 2010 to that in 2011?
Make the answer very short. 0.85. What is the ratio of the Claims(annual growth as % of broad money) in Costa Rica in 2010 to that in 2011?
Offer a very short reply. 0.4. What is the ratio of the Claims(annual growth as % of broad money) in Suriname in 2010 to that in 2011?
Offer a terse response. 0.63. What is the difference between the highest and the second highest Claims(annual growth as % of broad money) of Bulgaria?
Provide a succinct answer. 16.99. What is the difference between the highest and the second highest Claims(annual growth as % of broad money) of Colombia?
Offer a terse response. 4.91. What is the difference between the highest and the second highest Claims(annual growth as % of broad money) of Costa Rica?
Your answer should be compact. 0.89. What is the difference between the highest and the second highest Claims(annual growth as % of broad money) in Suriname?
Your response must be concise. 0.96. What is the difference between the highest and the lowest Claims(annual growth as % of broad money) of Bulgaria?
Make the answer very short. 44.02. What is the difference between the highest and the lowest Claims(annual growth as % of broad money) in Colombia?
Your response must be concise. 25.33. What is the difference between the highest and the lowest Claims(annual growth as % of broad money) in Costa Rica?
Your response must be concise. 22.36. What is the difference between the highest and the lowest Claims(annual growth as % of broad money) of Suriname?
Provide a short and direct response. 10.49. 